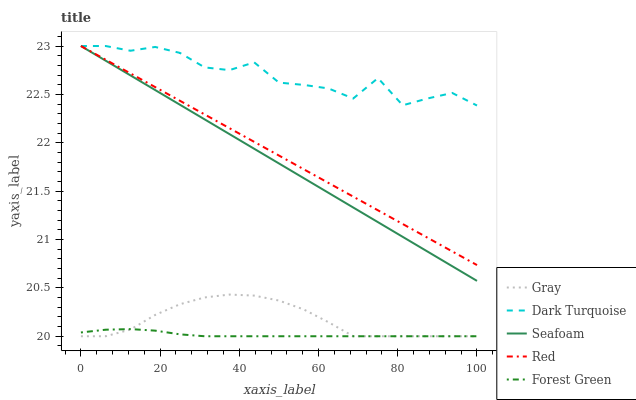Does Forest Green have the minimum area under the curve?
Answer yes or no. Yes. Does Dark Turquoise have the maximum area under the curve?
Answer yes or no. Yes. Does Seafoam have the minimum area under the curve?
Answer yes or no. No. Does Seafoam have the maximum area under the curve?
Answer yes or no. No. Is Red the smoothest?
Answer yes or no. Yes. Is Dark Turquoise the roughest?
Answer yes or no. Yes. Is Forest Green the smoothest?
Answer yes or no. No. Is Forest Green the roughest?
Answer yes or no. No. Does Gray have the lowest value?
Answer yes or no. Yes. Does Seafoam have the lowest value?
Answer yes or no. No. Does Dark Turquoise have the highest value?
Answer yes or no. Yes. Does Forest Green have the highest value?
Answer yes or no. No. Is Forest Green less than Dark Turquoise?
Answer yes or no. Yes. Is Red greater than Gray?
Answer yes or no. Yes. Does Red intersect Seafoam?
Answer yes or no. Yes. Is Red less than Seafoam?
Answer yes or no. No. Is Red greater than Seafoam?
Answer yes or no. No. Does Forest Green intersect Dark Turquoise?
Answer yes or no. No. 